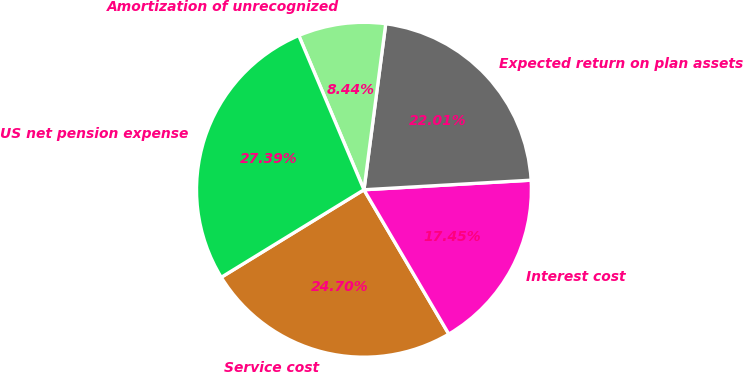Convert chart. <chart><loc_0><loc_0><loc_500><loc_500><pie_chart><fcel>Service cost<fcel>Interest cost<fcel>Expected return on plan assets<fcel>Amortization of unrecognized<fcel>US net pension expense<nl><fcel>24.7%<fcel>17.45%<fcel>22.01%<fcel>8.44%<fcel>27.39%<nl></chart> 